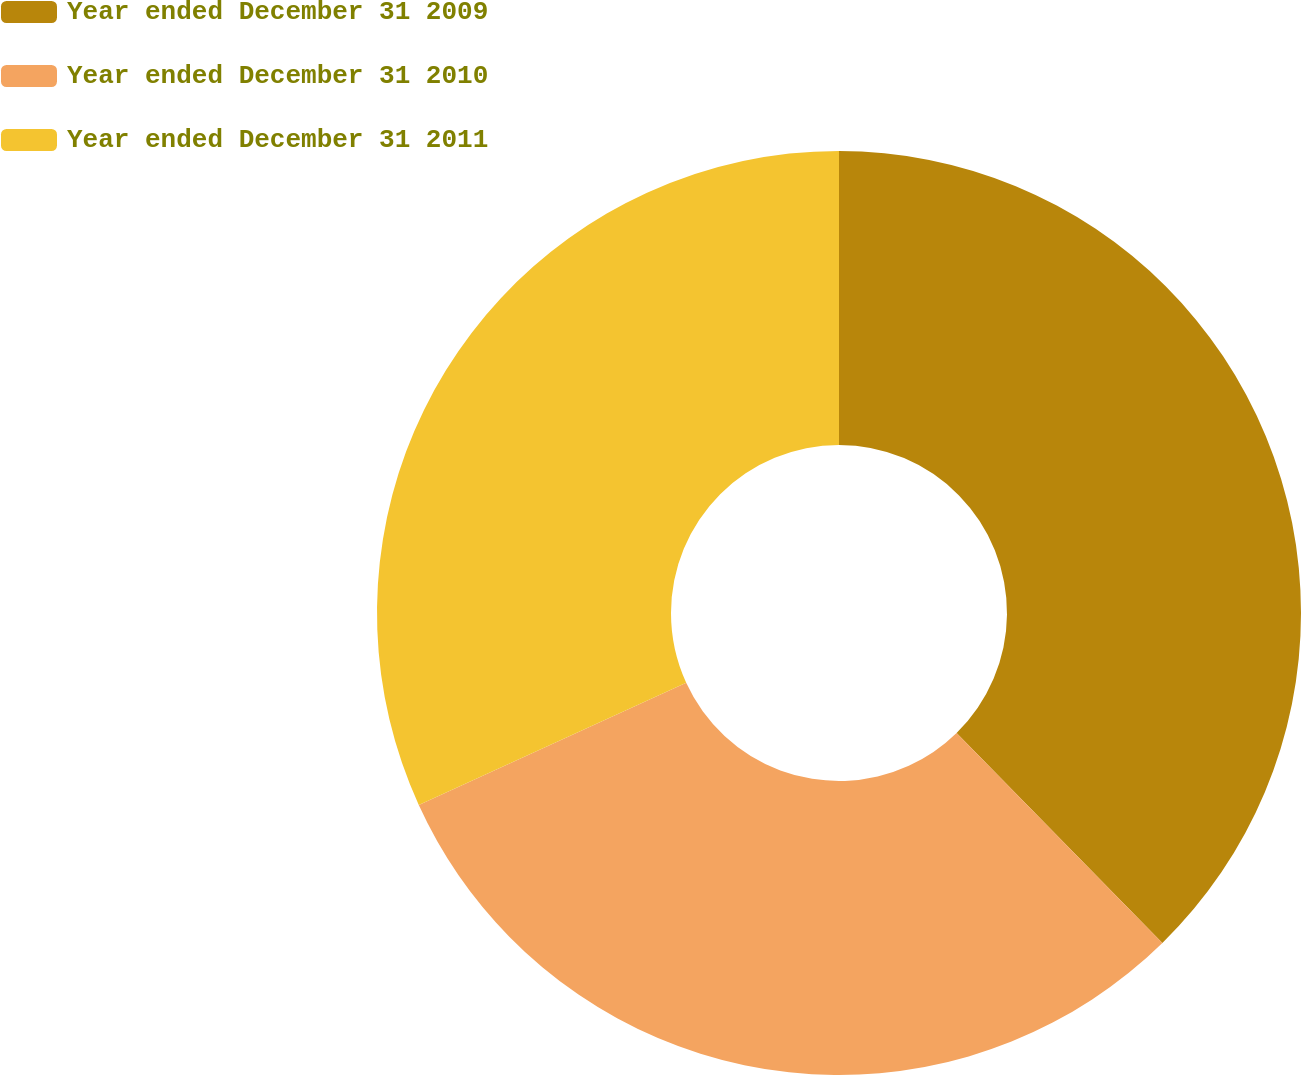Convert chart. <chart><loc_0><loc_0><loc_500><loc_500><pie_chart><fcel>Year ended December 31 2009<fcel>Year ended December 31 2010<fcel>Year ended December 31 2011<nl><fcel>37.66%<fcel>30.52%<fcel>31.82%<nl></chart> 